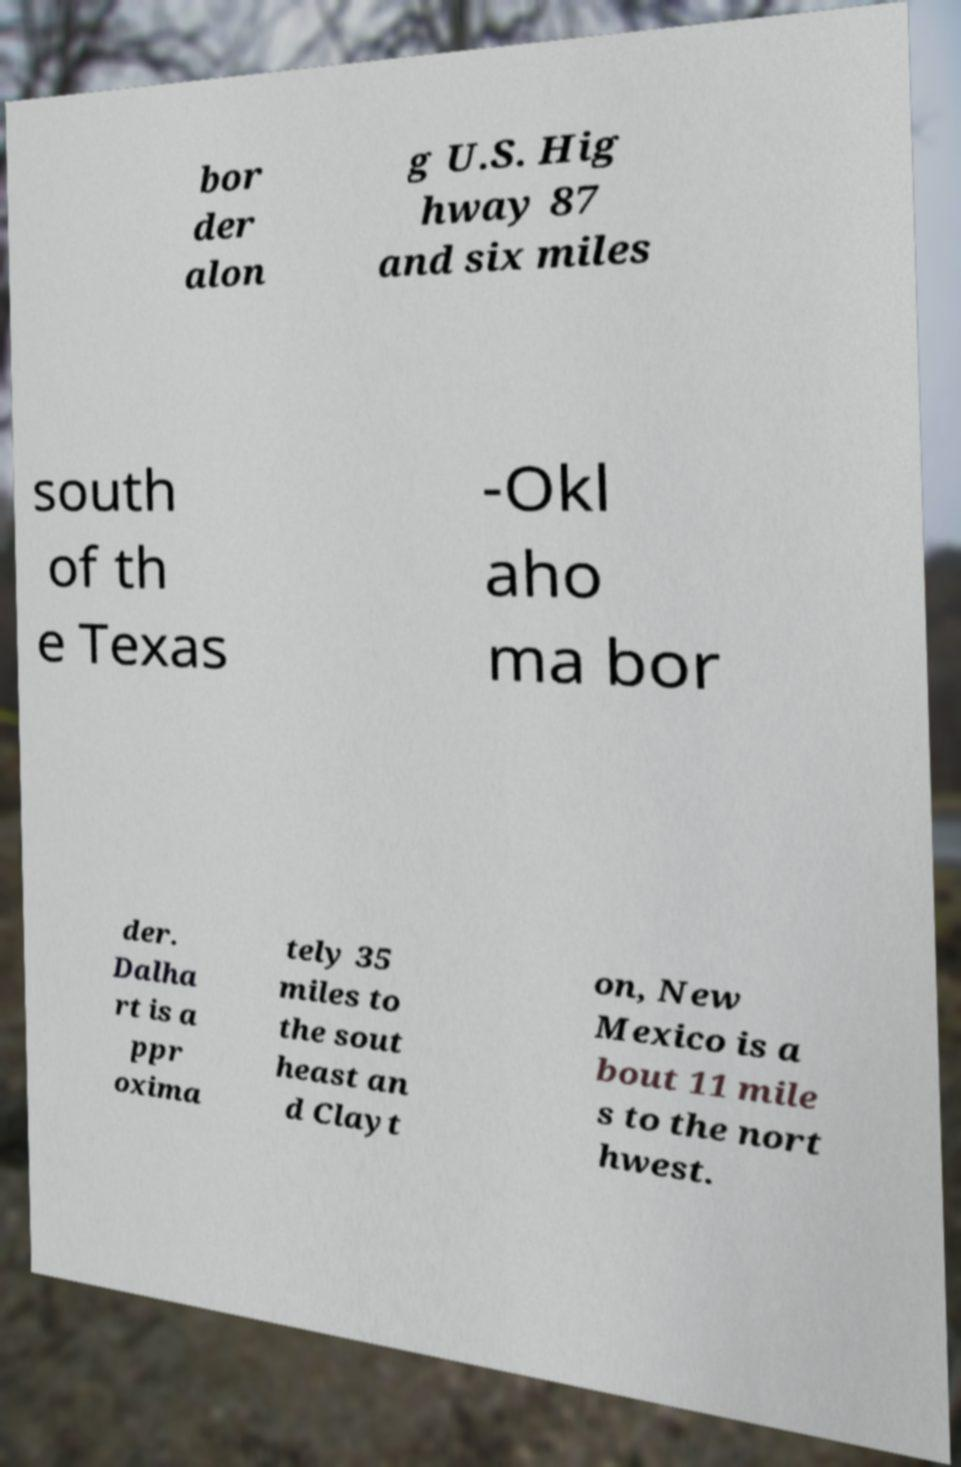Could you assist in decoding the text presented in this image and type it out clearly? bor der alon g U.S. Hig hway 87 and six miles south of th e Texas -Okl aho ma bor der. Dalha rt is a ppr oxima tely 35 miles to the sout heast an d Clayt on, New Mexico is a bout 11 mile s to the nort hwest. 